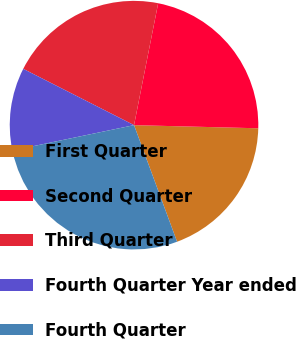Convert chart to OTSL. <chart><loc_0><loc_0><loc_500><loc_500><pie_chart><fcel>First Quarter<fcel>Second Quarter<fcel>Third Quarter<fcel>Fourth Quarter Year ended<fcel>Fourth Quarter<nl><fcel>18.97%<fcel>22.29%<fcel>20.63%<fcel>10.75%<fcel>27.36%<nl></chart> 